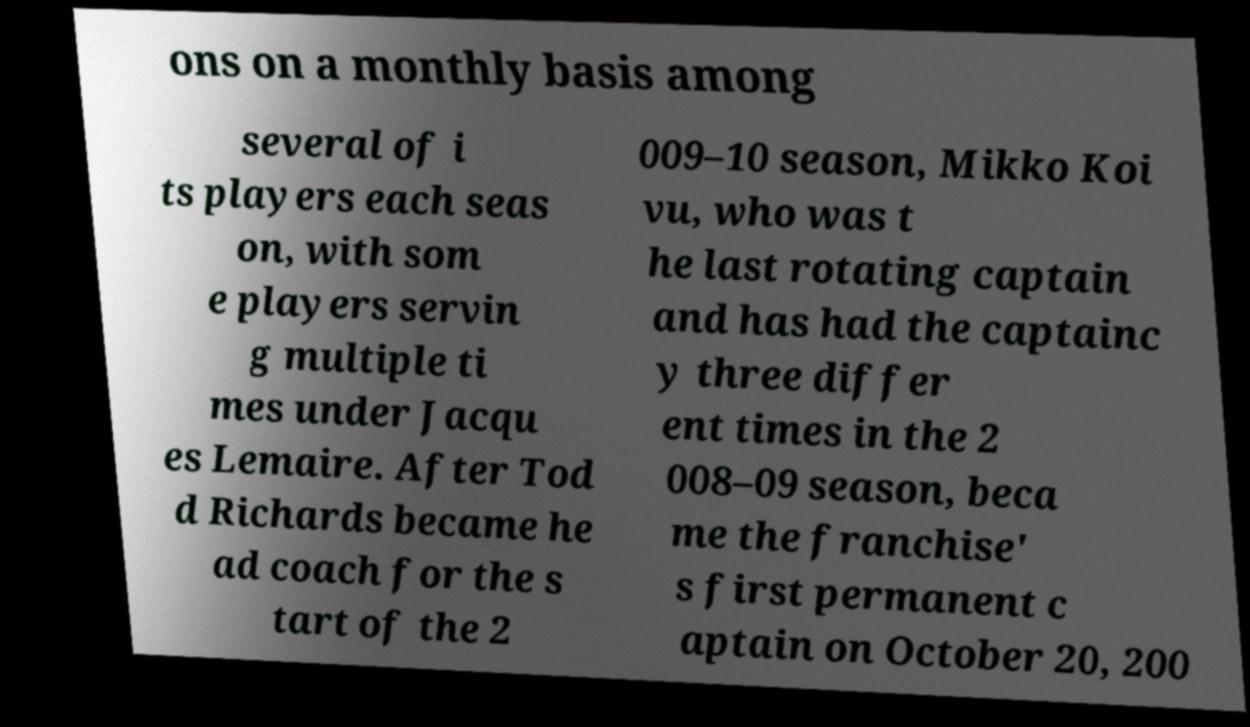What messages or text are displayed in this image? I need them in a readable, typed format. ons on a monthly basis among several of i ts players each seas on, with som e players servin g multiple ti mes under Jacqu es Lemaire. After Tod d Richards became he ad coach for the s tart of the 2 009–10 season, Mikko Koi vu, who was t he last rotating captain and has had the captainc y three differ ent times in the 2 008–09 season, beca me the franchise' s first permanent c aptain on October 20, 200 